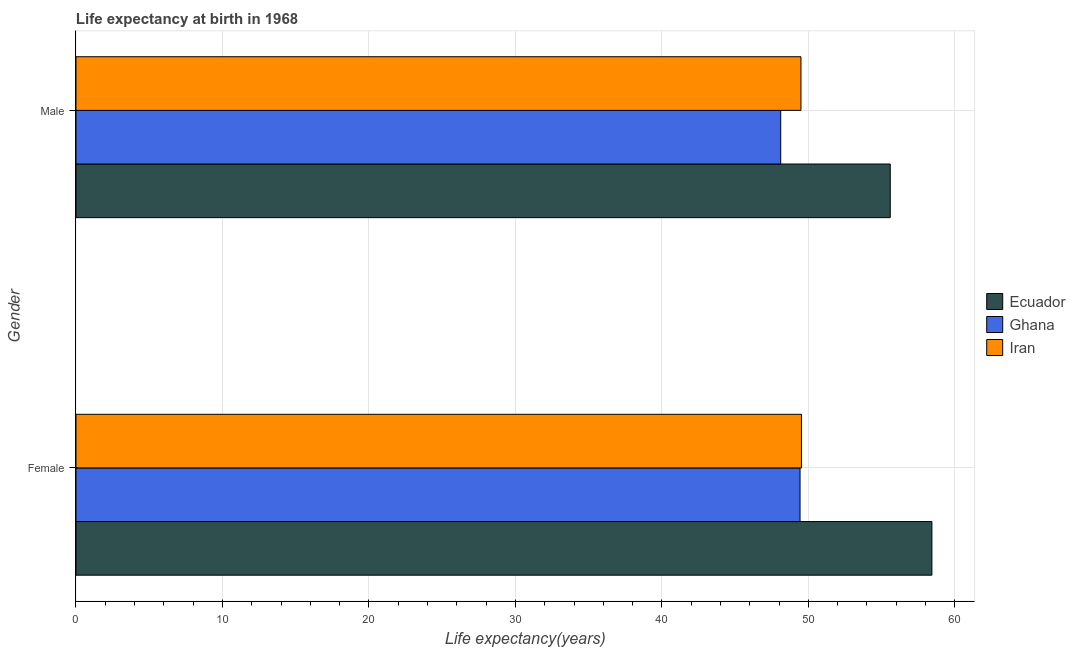Are the number of bars on each tick of the Y-axis equal?
Your answer should be very brief. Yes. What is the life expectancy(female) in Ghana?
Offer a terse response. 49.43. Across all countries, what is the maximum life expectancy(male)?
Make the answer very short. 55.59. Across all countries, what is the minimum life expectancy(female)?
Ensure brevity in your answer.  49.43. In which country was the life expectancy(female) maximum?
Make the answer very short. Ecuador. What is the total life expectancy(male) in the graph?
Keep it short and to the point. 153.2. What is the difference between the life expectancy(male) in Ghana and that in Ecuador?
Provide a short and direct response. -7.48. What is the difference between the life expectancy(male) in Ecuador and the life expectancy(female) in Ghana?
Ensure brevity in your answer.  6.16. What is the average life expectancy(male) per country?
Provide a short and direct response. 51.07. What is the difference between the life expectancy(male) and life expectancy(female) in Ecuador?
Your answer should be very brief. -2.84. In how many countries, is the life expectancy(female) greater than 20 years?
Your answer should be compact. 3. What is the ratio of the life expectancy(female) in Ghana to that in Iran?
Your answer should be compact. 1. Is the life expectancy(male) in Iran less than that in Ecuador?
Your answer should be very brief. Yes. What does the 2nd bar from the top in Male represents?
Your answer should be compact. Ghana. How many bars are there?
Your response must be concise. 6. Are all the bars in the graph horizontal?
Make the answer very short. Yes. What is the difference between two consecutive major ticks on the X-axis?
Give a very brief answer. 10. Does the graph contain grids?
Ensure brevity in your answer.  Yes. Where does the legend appear in the graph?
Offer a very short reply. Center right. What is the title of the graph?
Provide a succinct answer. Life expectancy at birth in 1968. What is the label or title of the X-axis?
Your response must be concise. Life expectancy(years). What is the label or title of the Y-axis?
Your answer should be compact. Gender. What is the Life expectancy(years) in Ecuador in Female?
Ensure brevity in your answer.  58.43. What is the Life expectancy(years) of Ghana in Female?
Ensure brevity in your answer.  49.43. What is the Life expectancy(years) in Iran in Female?
Provide a succinct answer. 49.53. What is the Life expectancy(years) of Ecuador in Male?
Provide a short and direct response. 55.59. What is the Life expectancy(years) of Ghana in Male?
Make the answer very short. 48.11. What is the Life expectancy(years) of Iran in Male?
Offer a very short reply. 49.49. Across all Gender, what is the maximum Life expectancy(years) of Ecuador?
Keep it short and to the point. 58.43. Across all Gender, what is the maximum Life expectancy(years) in Ghana?
Give a very brief answer. 49.43. Across all Gender, what is the maximum Life expectancy(years) in Iran?
Provide a short and direct response. 49.53. Across all Gender, what is the minimum Life expectancy(years) in Ecuador?
Your response must be concise. 55.59. Across all Gender, what is the minimum Life expectancy(years) in Ghana?
Offer a terse response. 48.11. Across all Gender, what is the minimum Life expectancy(years) of Iran?
Your response must be concise. 49.49. What is the total Life expectancy(years) in Ecuador in the graph?
Your answer should be compact. 114.02. What is the total Life expectancy(years) of Ghana in the graph?
Your answer should be very brief. 97.55. What is the total Life expectancy(years) of Iran in the graph?
Provide a short and direct response. 99.02. What is the difference between the Life expectancy(years) of Ecuador in Female and that in Male?
Provide a short and direct response. 2.84. What is the difference between the Life expectancy(years) in Ghana in Female and that in Male?
Ensure brevity in your answer.  1.32. What is the difference between the Life expectancy(years) in Iran in Female and that in Male?
Ensure brevity in your answer.  0.03. What is the difference between the Life expectancy(years) in Ecuador in Female and the Life expectancy(years) in Ghana in Male?
Offer a very short reply. 10.32. What is the difference between the Life expectancy(years) in Ecuador in Female and the Life expectancy(years) in Iran in Male?
Your answer should be compact. 8.94. What is the difference between the Life expectancy(years) in Ghana in Female and the Life expectancy(years) in Iran in Male?
Give a very brief answer. -0.06. What is the average Life expectancy(years) in Ecuador per Gender?
Give a very brief answer. 57.01. What is the average Life expectancy(years) of Ghana per Gender?
Ensure brevity in your answer.  48.77. What is the average Life expectancy(years) of Iran per Gender?
Give a very brief answer. 49.51. What is the difference between the Life expectancy(years) in Ecuador and Life expectancy(years) in Ghana in Female?
Give a very brief answer. 9. What is the difference between the Life expectancy(years) of Ecuador and Life expectancy(years) of Iran in Female?
Keep it short and to the point. 8.91. What is the difference between the Life expectancy(years) in Ghana and Life expectancy(years) in Iran in Female?
Offer a terse response. -0.1. What is the difference between the Life expectancy(years) of Ecuador and Life expectancy(years) of Ghana in Male?
Give a very brief answer. 7.48. What is the difference between the Life expectancy(years) of Ecuador and Life expectancy(years) of Iran in Male?
Provide a short and direct response. 6.1. What is the difference between the Life expectancy(years) of Ghana and Life expectancy(years) of Iran in Male?
Keep it short and to the point. -1.38. What is the ratio of the Life expectancy(years) of Ecuador in Female to that in Male?
Ensure brevity in your answer.  1.05. What is the ratio of the Life expectancy(years) in Ghana in Female to that in Male?
Ensure brevity in your answer.  1.03. What is the difference between the highest and the second highest Life expectancy(years) in Ecuador?
Your answer should be compact. 2.84. What is the difference between the highest and the second highest Life expectancy(years) in Ghana?
Provide a short and direct response. 1.32. What is the difference between the highest and the second highest Life expectancy(years) of Iran?
Your answer should be very brief. 0.03. What is the difference between the highest and the lowest Life expectancy(years) of Ecuador?
Keep it short and to the point. 2.84. What is the difference between the highest and the lowest Life expectancy(years) in Ghana?
Offer a terse response. 1.32. What is the difference between the highest and the lowest Life expectancy(years) of Iran?
Your answer should be very brief. 0.03. 